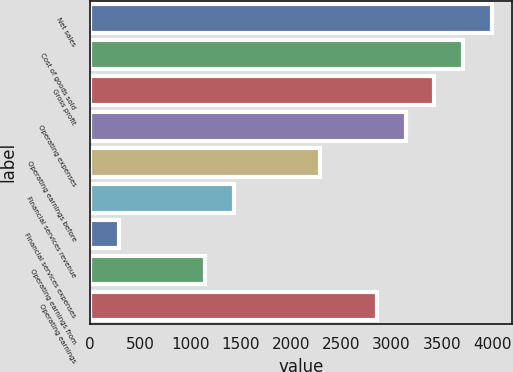Convert chart to OTSL. <chart><loc_0><loc_0><loc_500><loc_500><bar_chart><fcel>Net sales<fcel>Cost of goods sold<fcel>Gross profit<fcel>Operating expenses<fcel>Operating earnings before<fcel>Financial services revenue<fcel>Financial services expenses<fcel>Operating earnings from<fcel>Operating earnings<nl><fcel>3994.04<fcel>3709.08<fcel>3424.12<fcel>3139.16<fcel>2284.28<fcel>1429.4<fcel>289.56<fcel>1144.44<fcel>2854.2<nl></chart> 